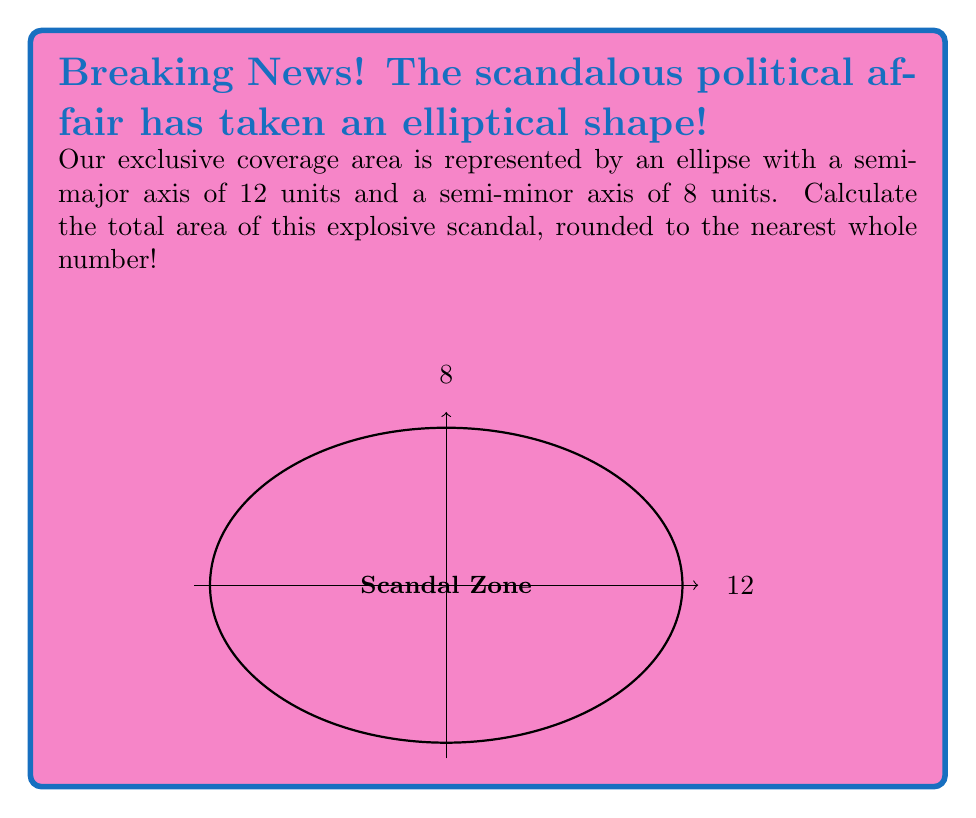What is the answer to this math problem? To calculate the area of an ellipse, we use the formula:

$$A = \pi ab$$

Where:
$a$ is the length of the semi-major axis
$b$ is the length of the semi-minor axis

Given:
$a = 12$ units
$b = 8$ units

Let's substitute these values into our formula:

$$A = \pi (12)(8)$$

$$A = 96\pi$$

Now, let's calculate this value:

$$A \approx 301.5929$$

Rounding to the nearest whole number:

$$A \approx 302$$

Therefore, the area of our scandalous political coverage ellipse is approximately 302 square units.
Answer: 302 square units 